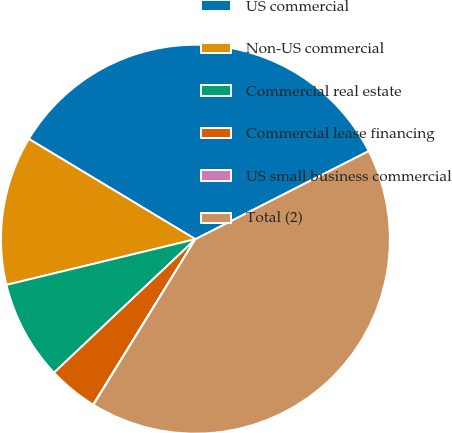Convert chart to OTSL. <chart><loc_0><loc_0><loc_500><loc_500><pie_chart><fcel>US commercial<fcel>Non-US commercial<fcel>Commercial real estate<fcel>Commercial lease financing<fcel>US small business commercial<fcel>Total (2)<nl><fcel>33.89%<fcel>12.4%<fcel>8.27%<fcel>4.15%<fcel>0.02%<fcel>41.27%<nl></chart> 